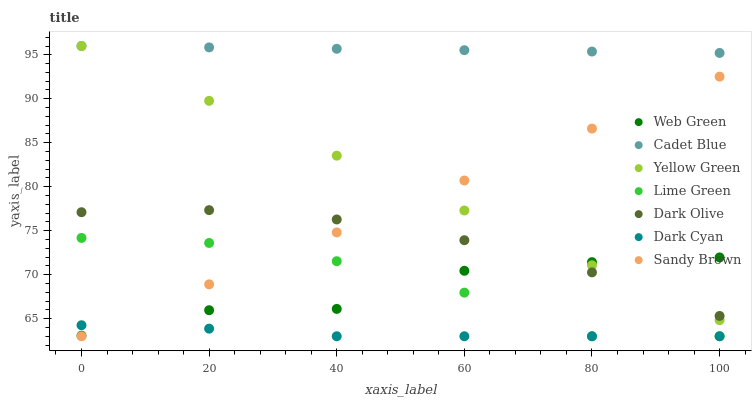Does Dark Cyan have the minimum area under the curve?
Answer yes or no. Yes. Does Cadet Blue have the maximum area under the curve?
Answer yes or no. Yes. Does Yellow Green have the minimum area under the curve?
Answer yes or no. No. Does Yellow Green have the maximum area under the curve?
Answer yes or no. No. Is Yellow Green the smoothest?
Answer yes or no. Yes. Is Web Green the roughest?
Answer yes or no. Yes. Is Sandy Brown the smoothest?
Answer yes or no. No. Is Sandy Brown the roughest?
Answer yes or no. No. Does Sandy Brown have the lowest value?
Answer yes or no. Yes. Does Yellow Green have the lowest value?
Answer yes or no. No. Does Yellow Green have the highest value?
Answer yes or no. Yes. Does Sandy Brown have the highest value?
Answer yes or no. No. Is Web Green less than Cadet Blue?
Answer yes or no. Yes. Is Dark Olive greater than Lime Green?
Answer yes or no. Yes. Does Sandy Brown intersect Lime Green?
Answer yes or no. Yes. Is Sandy Brown less than Lime Green?
Answer yes or no. No. Is Sandy Brown greater than Lime Green?
Answer yes or no. No. Does Web Green intersect Cadet Blue?
Answer yes or no. No. 